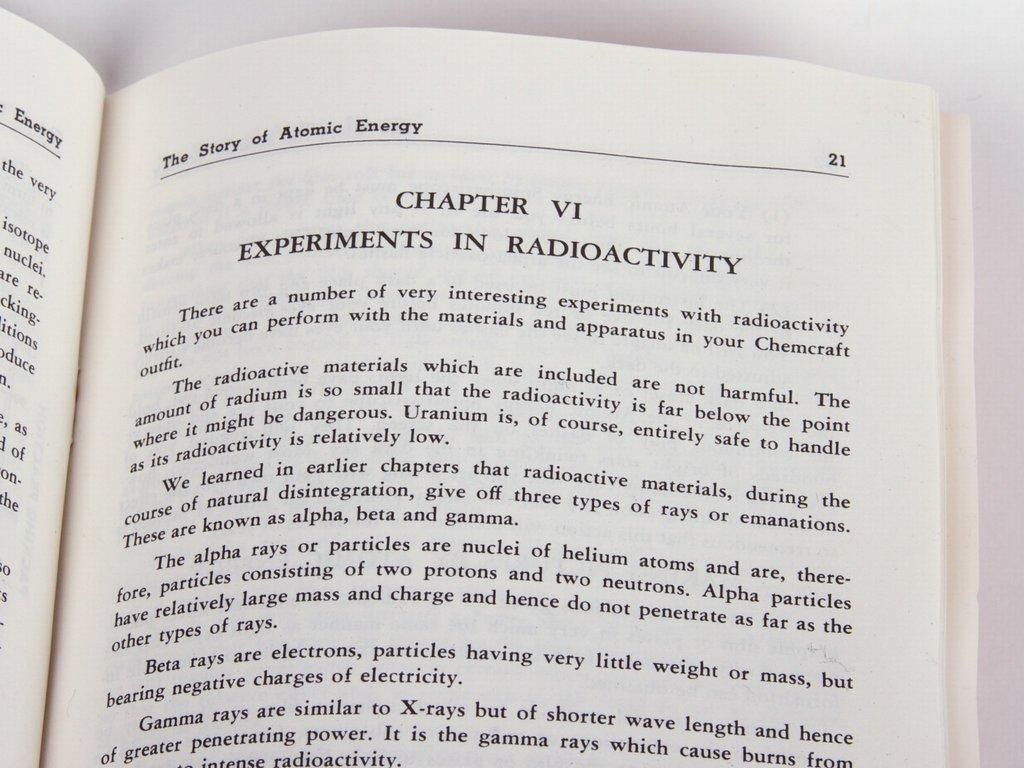<image>
Create a compact narrative representing the image presented. The Story of Atomic Energy is opened to Chapter 6 